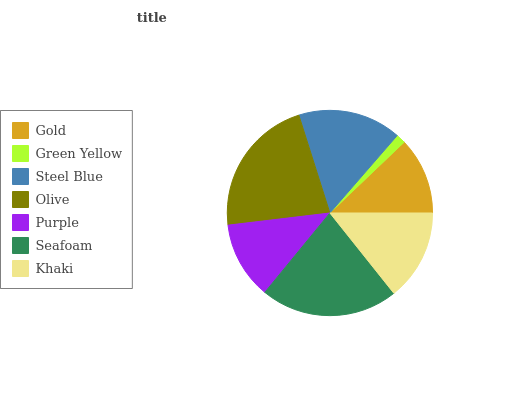Is Green Yellow the minimum?
Answer yes or no. Yes. Is Olive the maximum?
Answer yes or no. Yes. Is Steel Blue the minimum?
Answer yes or no. No. Is Steel Blue the maximum?
Answer yes or no. No. Is Steel Blue greater than Green Yellow?
Answer yes or no. Yes. Is Green Yellow less than Steel Blue?
Answer yes or no. Yes. Is Green Yellow greater than Steel Blue?
Answer yes or no. No. Is Steel Blue less than Green Yellow?
Answer yes or no. No. Is Khaki the high median?
Answer yes or no. Yes. Is Khaki the low median?
Answer yes or no. Yes. Is Steel Blue the high median?
Answer yes or no. No. Is Steel Blue the low median?
Answer yes or no. No. 